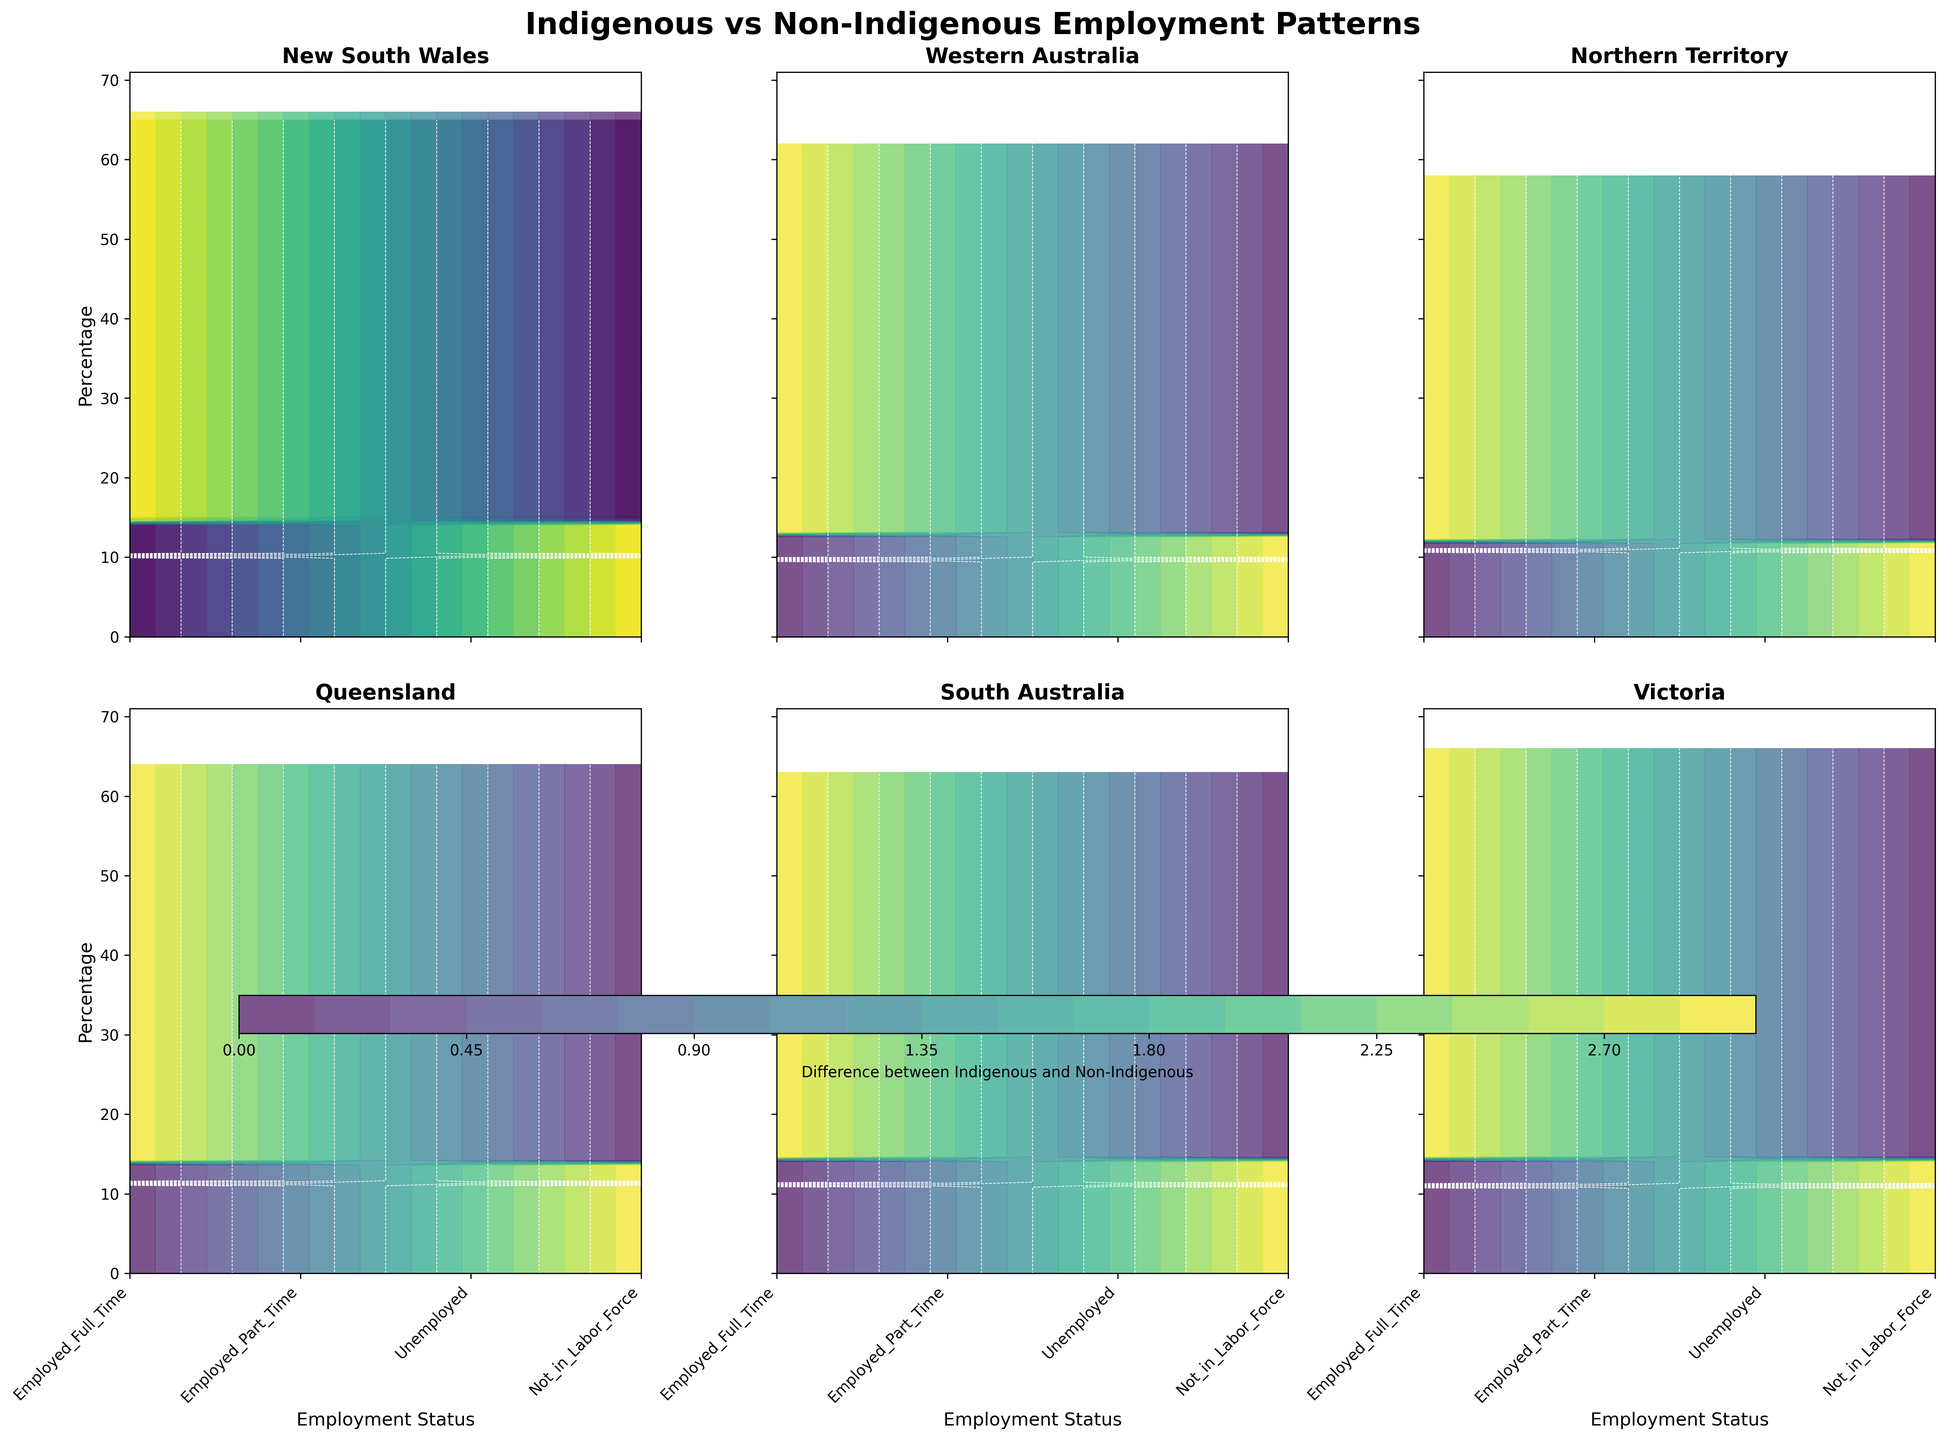Which region has the highest percentage of indigenous people employed full-time? By examining the y-axis values for the 'Employed_Full_Time' category across different regions, we can compare the heights.
Answer: New South Wales What's the title of the figure? The title is usually located at the top center of the figure.
Answer: Indigenous vs Non-Indigenous Employment Patterns What is the color scheme used in the contour plot? The color scheme can be determined by looking at the colors used in the plot.
Answer: Viridis Which regions show a greater difference between indigenous and non-indigenous unemployment rates? By comparing the contour lines' distances for the 'Unemployed' category across regions, regions with larger gaps indicate greater differences.
Answer: Northern Territory and Western Australia What is the percentage of non-indigenous people employed part-time in Victoria? Look at the y-axis value corresponding to the 'Employed_Part_Time' category for Victoria.
Answer: 18% Which region has the smallest percentage of indigenous people not in the labor force? Compare the y-axis values for the 'Not_in_Labor_Force' category across different regions and identify the smallest one.
Answer: Northern Territory What employment category has the smallest difference between indigenous and non-indigenous populations in South Australia? By looking at the contour lines for each employment category in South Australia, the smallest gap indicates the smallest difference.
Answer: Employed_Part_Time Between which employment statuses do you observe the biggest difference in New South Wales? Check the contour plot for New South Wales and identify where the contour lines are the farthest apart.
Answer: Unemployed How does the full-time employment rate of indigenous people in Queensland compare to that in Victoria? Compare the y-axis values for 'Employed_Full_Time' in the Queensland and Victoria plots.
Answer: Queensland: 47%, Victoria: 46% In which region is the unemployment rate for indigenous people the highest? Look for the highest y-axis value in the 'Unemployed' category across all regions.
Answer: Northern Territory 